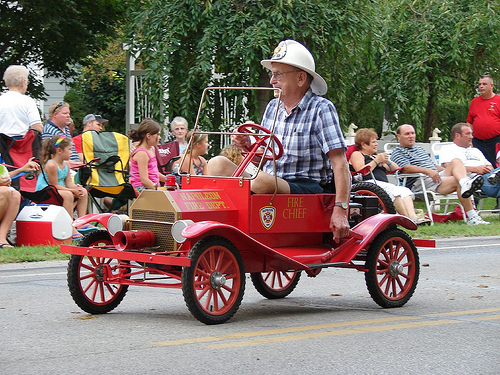<image>
Is there a girl on the chair? Yes. Looking at the image, I can see the girl is positioned on top of the chair, with the chair providing support. Is there a man next to the car? No. The man is not positioned next to the car. They are located in different areas of the scene. 